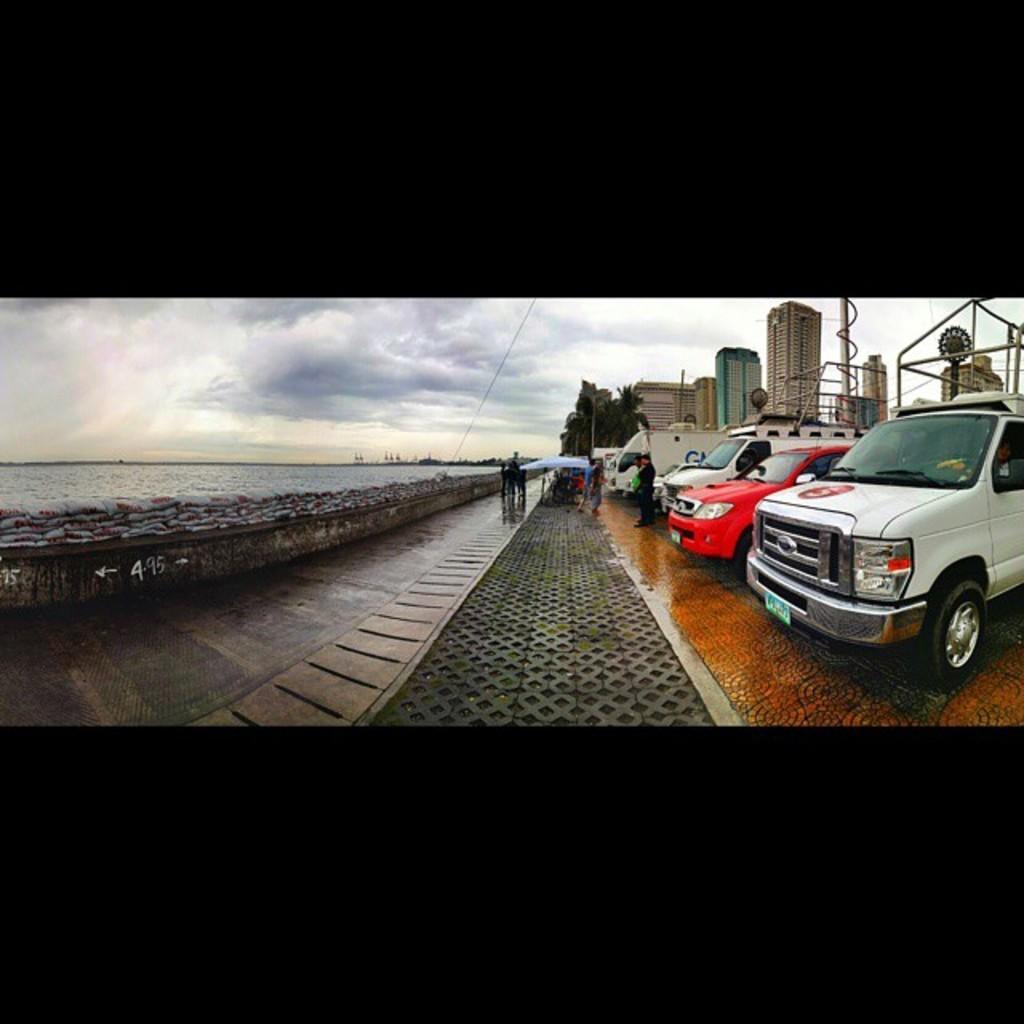In one or two sentences, can you explain what this image depicts? On the right side, we see vehicles parked on the road. Beside that, we see people are standing. We see people are sitting under the blue tent. On the left side, we see a wall and water. This water might be in the lake. There are trees and buildings in the background. At the top, we see the sky. This picture might be an edited image. At the top and the bottom of the picture, it is black in color. 